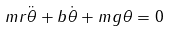Convert formula to latex. <formula><loc_0><loc_0><loc_500><loc_500>m r \ddot { \theta } + b \dot { \theta } + m g \theta = 0</formula> 